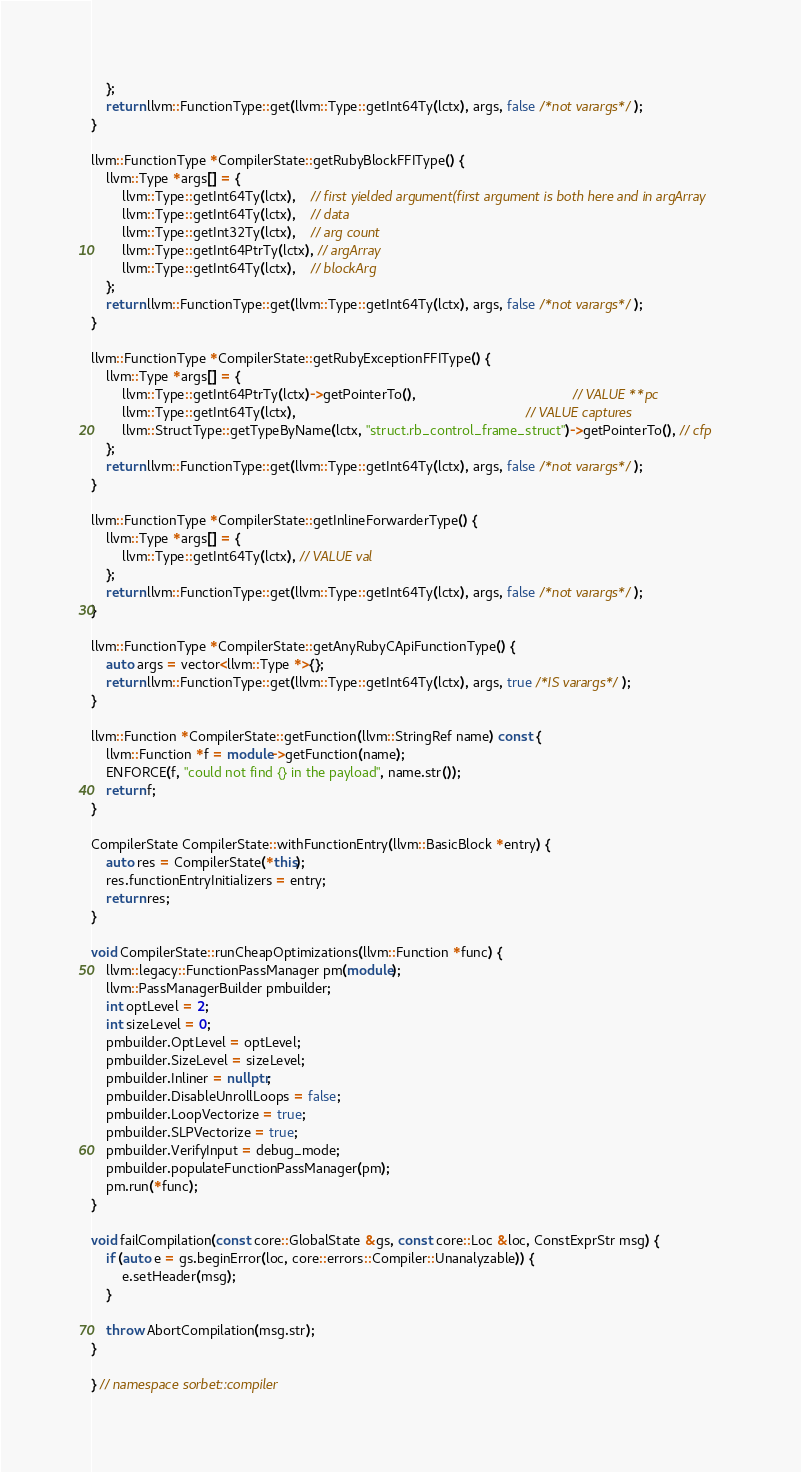Convert code to text. <code><loc_0><loc_0><loc_500><loc_500><_C++_>    };
    return llvm::FunctionType::get(llvm::Type::getInt64Ty(lctx), args, false /*not varargs*/);
}

llvm::FunctionType *CompilerState::getRubyBlockFFIType() {
    llvm::Type *args[] = {
        llvm::Type::getInt64Ty(lctx),    // first yielded argument(first argument is both here and in argArray
        llvm::Type::getInt64Ty(lctx),    // data
        llvm::Type::getInt32Ty(lctx),    // arg count
        llvm::Type::getInt64PtrTy(lctx), // argArray
        llvm::Type::getInt64Ty(lctx),    // blockArg
    };
    return llvm::FunctionType::get(llvm::Type::getInt64Ty(lctx), args, false /*not varargs*/);
}

llvm::FunctionType *CompilerState::getRubyExceptionFFIType() {
    llvm::Type *args[] = {
        llvm::Type::getInt64PtrTy(lctx)->getPointerTo(),                                         // VALUE **pc
        llvm::Type::getInt64Ty(lctx),                                                            // VALUE captures
        llvm::StructType::getTypeByName(lctx, "struct.rb_control_frame_struct")->getPointerTo(), // cfp
    };
    return llvm::FunctionType::get(llvm::Type::getInt64Ty(lctx), args, false /*not varargs*/);
}

llvm::FunctionType *CompilerState::getInlineForwarderType() {
    llvm::Type *args[] = {
        llvm::Type::getInt64Ty(lctx), // VALUE val
    };
    return llvm::FunctionType::get(llvm::Type::getInt64Ty(lctx), args, false /*not varargs*/);
}

llvm::FunctionType *CompilerState::getAnyRubyCApiFunctionType() {
    auto args = vector<llvm::Type *>{};
    return llvm::FunctionType::get(llvm::Type::getInt64Ty(lctx), args, true /*IS varargs*/);
}

llvm::Function *CompilerState::getFunction(llvm::StringRef name) const {
    llvm::Function *f = module->getFunction(name);
    ENFORCE(f, "could not find {} in the payload", name.str());
    return f;
}

CompilerState CompilerState::withFunctionEntry(llvm::BasicBlock *entry) {
    auto res = CompilerState(*this);
    res.functionEntryInitializers = entry;
    return res;
}

void CompilerState::runCheapOptimizations(llvm::Function *func) {
    llvm::legacy::FunctionPassManager pm(module);
    llvm::PassManagerBuilder pmbuilder;
    int optLevel = 2;
    int sizeLevel = 0;
    pmbuilder.OptLevel = optLevel;
    pmbuilder.SizeLevel = sizeLevel;
    pmbuilder.Inliner = nullptr;
    pmbuilder.DisableUnrollLoops = false;
    pmbuilder.LoopVectorize = true;
    pmbuilder.SLPVectorize = true;
    pmbuilder.VerifyInput = debug_mode;
    pmbuilder.populateFunctionPassManager(pm);
    pm.run(*func);
}

void failCompilation(const core::GlobalState &gs, const core::Loc &loc, ConstExprStr msg) {
    if (auto e = gs.beginError(loc, core::errors::Compiler::Unanalyzable)) {
        e.setHeader(msg);
    }

    throw AbortCompilation(msg.str);
}

} // namespace sorbet::compiler
</code> 